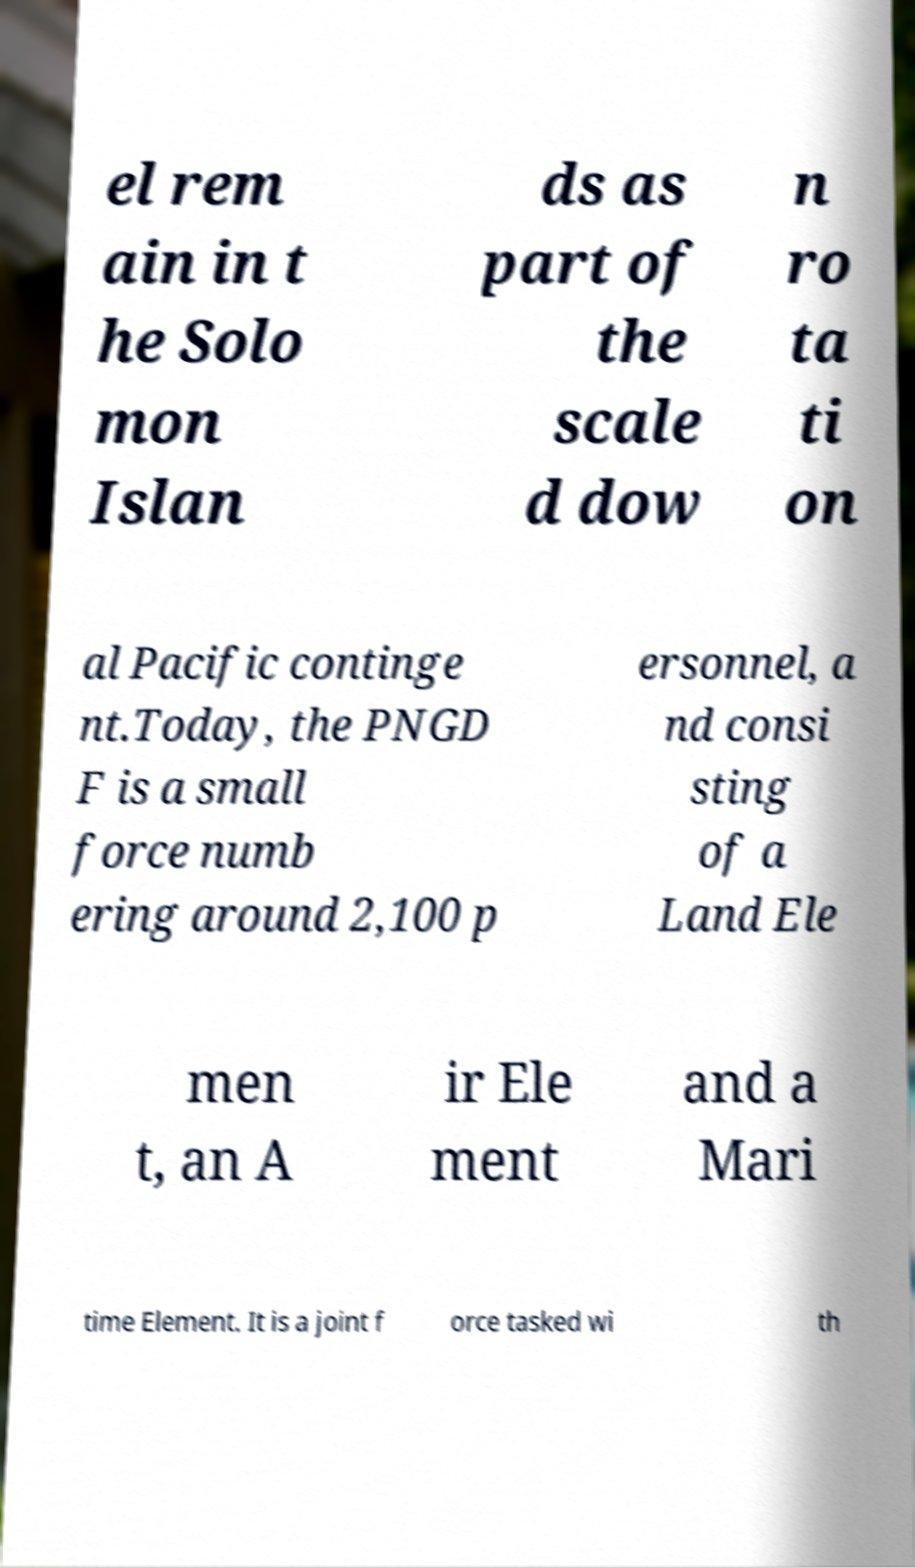Could you assist in decoding the text presented in this image and type it out clearly? el rem ain in t he Solo mon Islan ds as part of the scale d dow n ro ta ti on al Pacific continge nt.Today, the PNGD F is a small force numb ering around 2,100 p ersonnel, a nd consi sting of a Land Ele men t, an A ir Ele ment and a Mari time Element. It is a joint f orce tasked wi th 